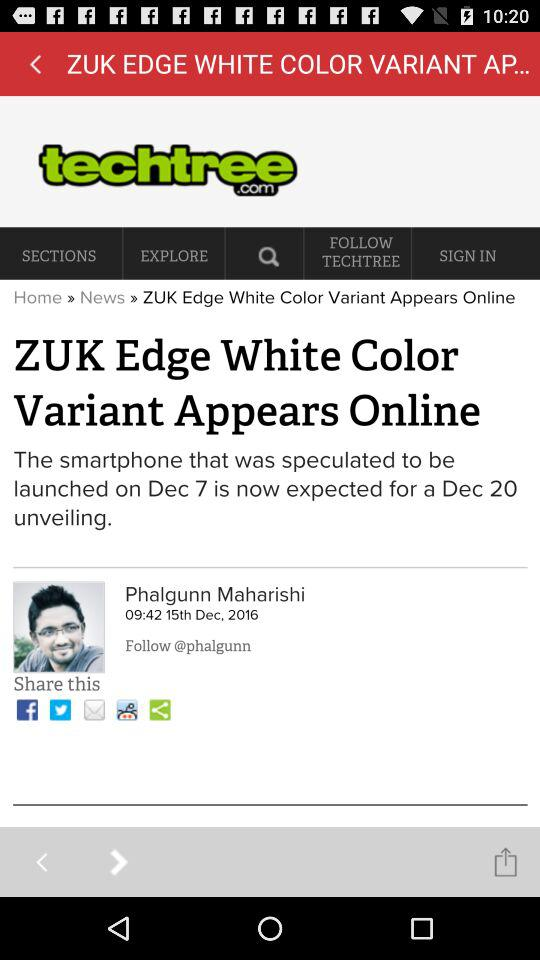What is the publication date? The publication date is December 15, 2016. 